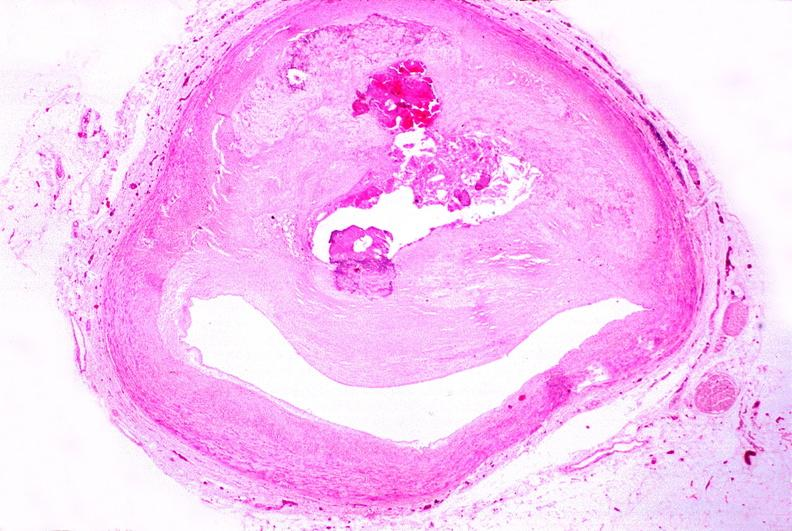does this image show atherosclerosis?
Answer the question using a single word or phrase. Yes 